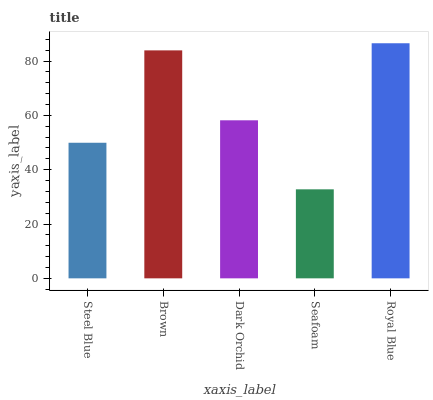Is Seafoam the minimum?
Answer yes or no. Yes. Is Royal Blue the maximum?
Answer yes or no. Yes. Is Brown the minimum?
Answer yes or no. No. Is Brown the maximum?
Answer yes or no. No. Is Brown greater than Steel Blue?
Answer yes or no. Yes. Is Steel Blue less than Brown?
Answer yes or no. Yes. Is Steel Blue greater than Brown?
Answer yes or no. No. Is Brown less than Steel Blue?
Answer yes or no. No. Is Dark Orchid the high median?
Answer yes or no. Yes. Is Dark Orchid the low median?
Answer yes or no. Yes. Is Steel Blue the high median?
Answer yes or no. No. Is Steel Blue the low median?
Answer yes or no. No. 